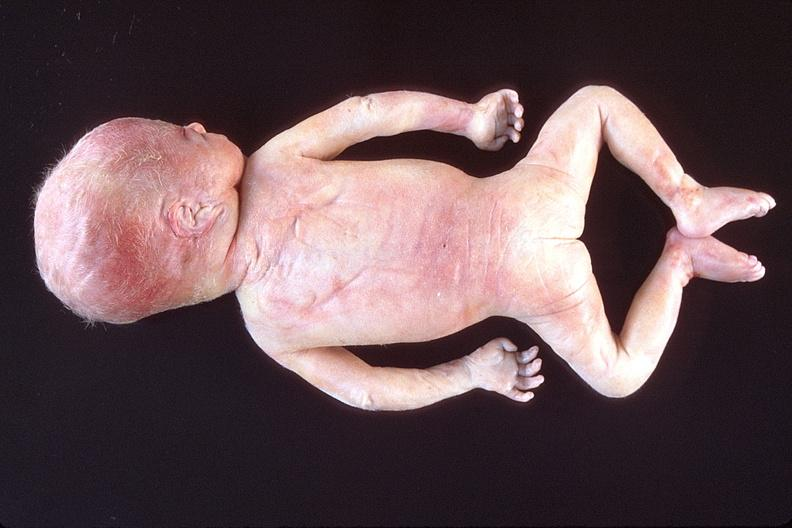does chest and abdomen slide show hyaline membrane disease?
Answer the question using a single word or phrase. No 